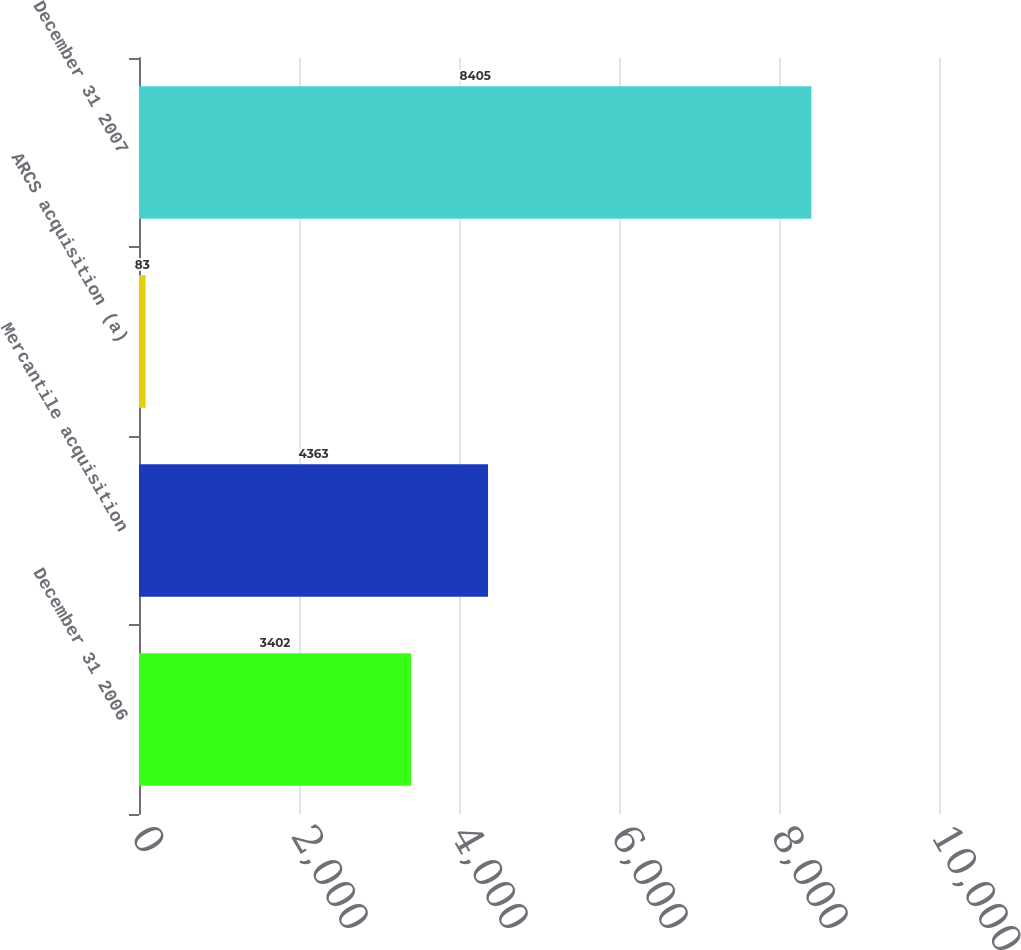<chart> <loc_0><loc_0><loc_500><loc_500><bar_chart><fcel>December 31 2006<fcel>Mercantile acquisition<fcel>ARCS acquisition (a)<fcel>December 31 2007<nl><fcel>3402<fcel>4363<fcel>83<fcel>8405<nl></chart> 